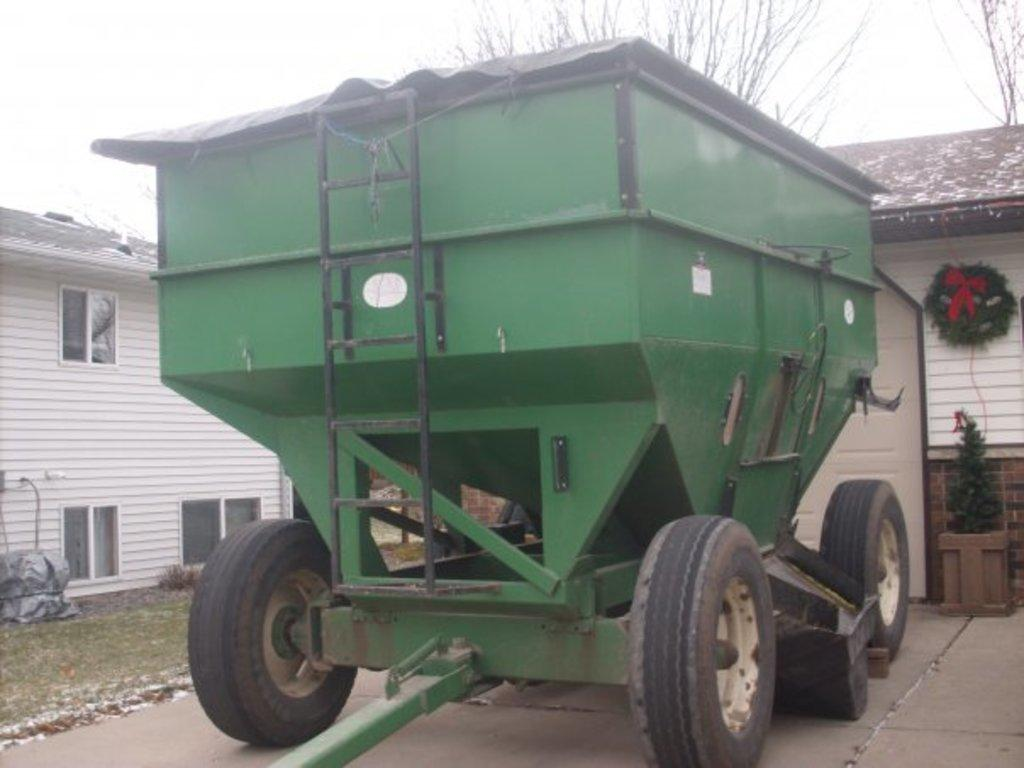What type of vehicle is in the image? There is a vehicle in the image, but the specific type is not mentioned. What can be seen growing in the image? There is grass in the image. What type of structures are present in the image? There are houses in the image. What feature is present on the houses in the image? There are windows in the image. What type of vegetation is in the image? There is a plant in the image. What is visible in the background of the image? The sky is visible in the background of the image. Can you tell me how many strands of hair are visible on the plant in the image? There is no mention of hair in the image, as it features a vehicle, grass, houses, windows, a plant, and the sky. What type of recess can be seen in the image? There is no recess present in the image. 